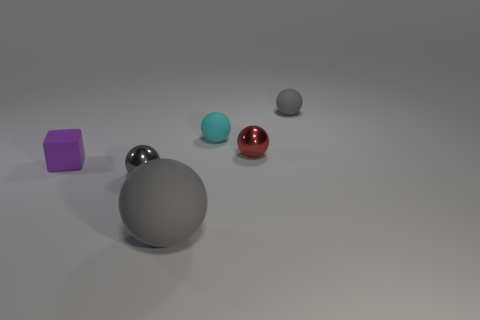Subtract all gray blocks. How many gray spheres are left? 3 Subtract all red balls. How many balls are left? 4 Subtract all big gray balls. How many balls are left? 4 Subtract all green spheres. Subtract all green cubes. How many spheres are left? 5 Add 4 small matte things. How many objects exist? 10 Subtract all cubes. How many objects are left? 5 Subtract 0 cyan cubes. How many objects are left? 6 Subtract all small things. Subtract all gray metallic blocks. How many objects are left? 1 Add 3 gray balls. How many gray balls are left? 6 Add 6 blue matte things. How many blue matte things exist? 6 